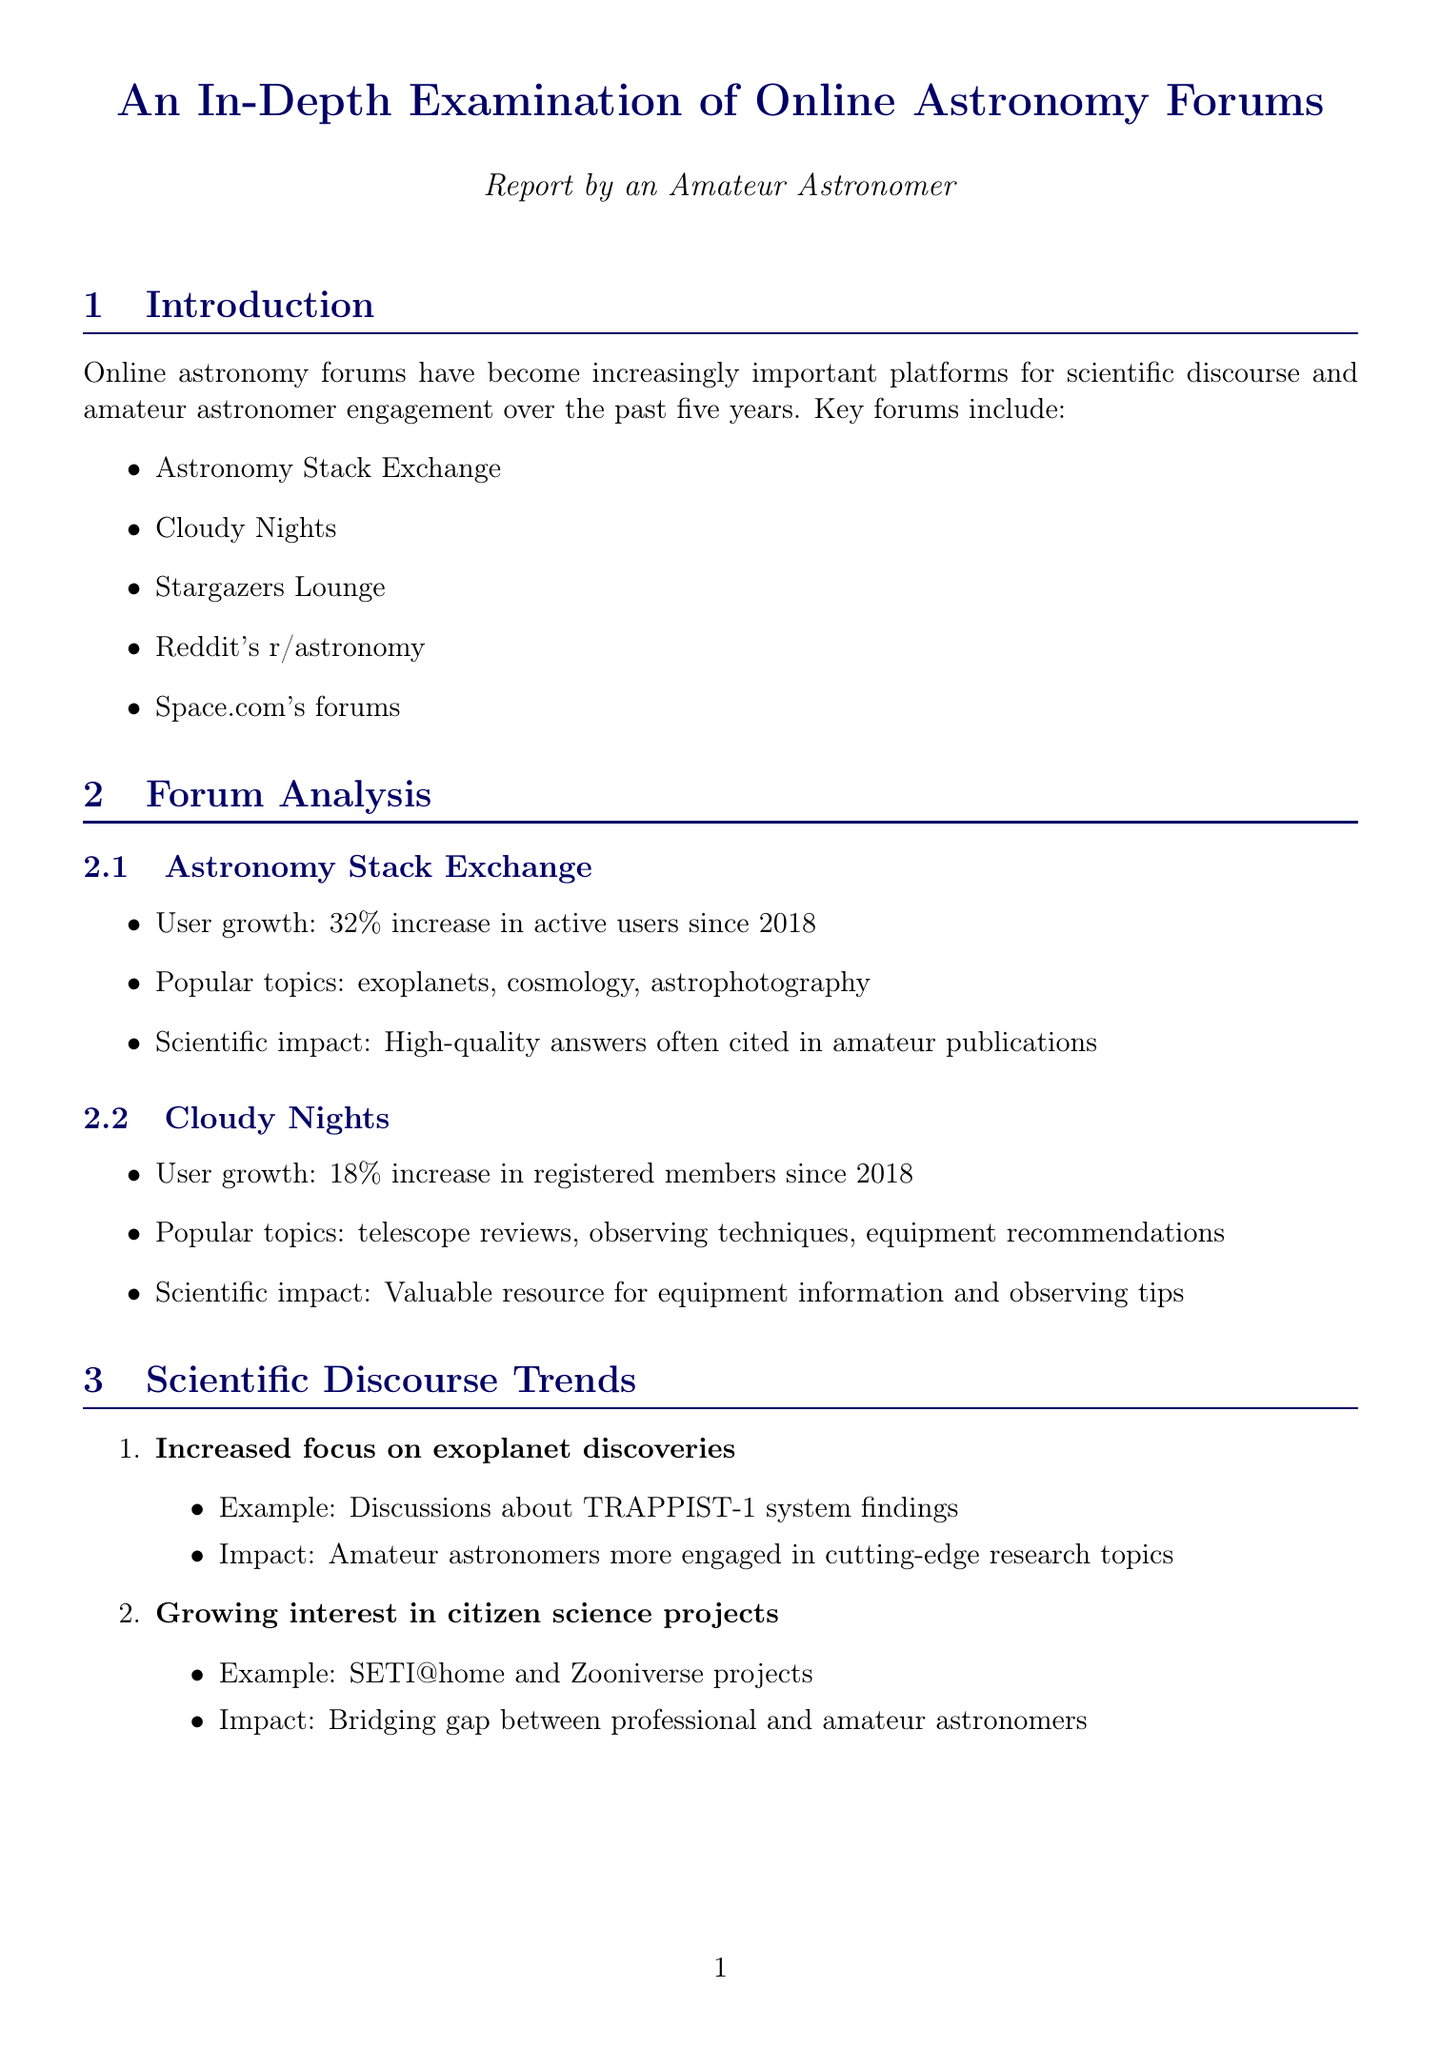What is the user growth percentage for Astronomy Stack Exchange since 2018? The report states that there has been a 32% increase in active users for Astronomy Stack Exchange since 2018.
Answer: 32% What are two popular topics discussed on Cloudy Nights? The document lists popular topics discussed on Cloudy Nights, which include telescope reviews and observing techniques.
Answer: Telescope reviews, observing techniques What is the total number of posts in online astronomy forums in 2023? The total number of posts reported for 2023 is given as 1,875,000.
Answer: 1,875,000 What trend has increased engagement related to citizen science projects? The report mentions a growing interest in citizen science projects affecting amateur astronomer engagement.
Answer: Growing interest in citizen science projects Which book is praised for accuracy in describing space operations? The document states that "An Astronaut's Guide to Life on Earth" by Chris Hadfield is praised for its accuracy.
Answer: An Astronaut's Guide to Life on Earth What challenge is mentioned regarding online astronomy forums? The document identifies misinformation spread as a key challenge faced by online astronomy forums.
Answer: Misinformation spread How many average daily active users were there in 2018? The report specifies that the average daily active users in 2018 was 50,000.
Answer: 50,000 What potential impact of collaboration with professional institutions is highlighted? The document notes the potential impact as increased citizen science participation through collaboration with professional institutions.
Answer: Increased citizen science participation 